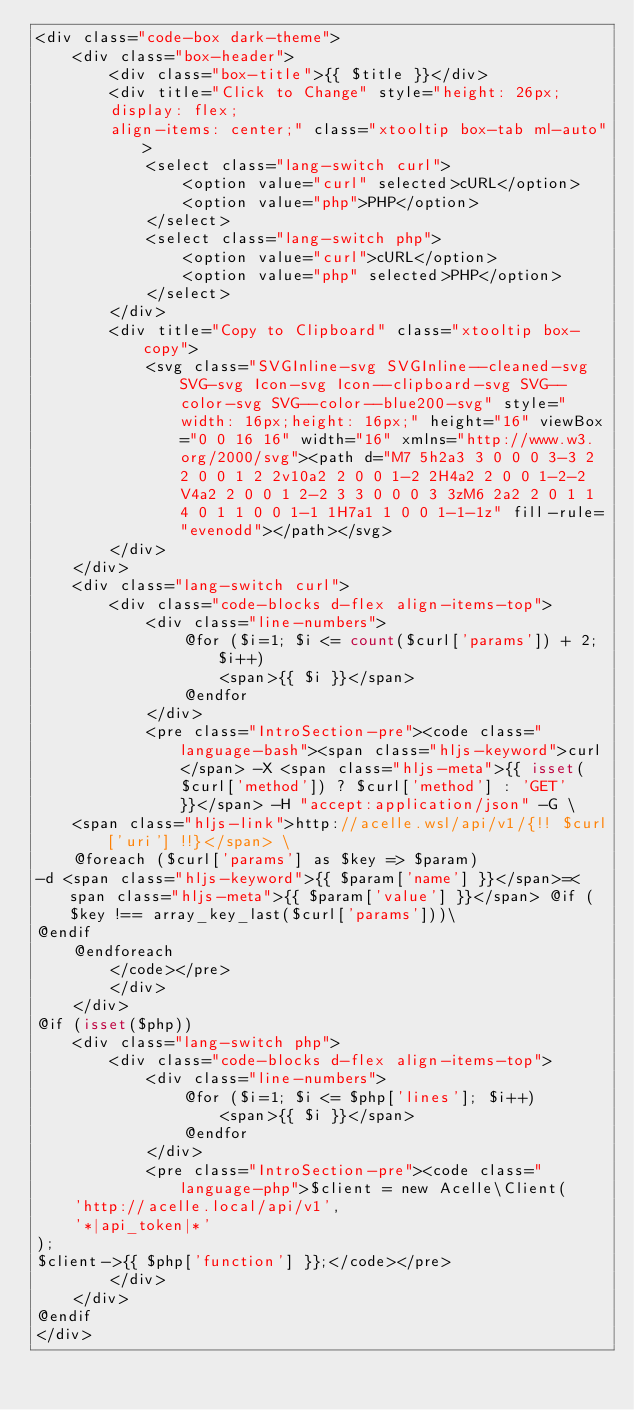Convert code to text. <code><loc_0><loc_0><loc_500><loc_500><_PHP_><div class="code-box dark-theme">
    <div class="box-header">
        <div class="box-title">{{ $title }}</div>
        <div title="Click to Change" style="height: 26px;
        display: flex;
        align-items: center;" class="xtooltip box-tab ml-auto">
            <select class="lang-switch curl">
                <option value="curl" selected>cURL</option>
                <option value="php">PHP</option>
            </select>
            <select class="lang-switch php">
                <option value="curl">cURL</option>
                <option value="php" selected>PHP</option>
            </select>
        </div>
        <div title="Copy to Clipboard" class="xtooltip box-copy">
            <svg class="SVGInline-svg SVGInline--cleaned-svg SVG-svg Icon-svg Icon--clipboard-svg SVG--color-svg SVG--color--blue200-svg" style="width: 16px;height: 16px;" height="16" viewBox="0 0 16 16" width="16" xmlns="http://www.w3.org/2000/svg"><path d="M7 5h2a3 3 0 0 0 3-3 2 2 0 0 1 2 2v10a2 2 0 0 1-2 2H4a2 2 0 0 1-2-2V4a2 2 0 0 1 2-2 3 3 0 0 0 3 3zM6 2a2 2 0 1 1 4 0 1 1 0 0 1-1 1H7a1 1 0 0 1-1-1z" fill-rule="evenodd"></path></svg>
        </div>
    </div>
    <div class="lang-switch curl">
        <div class="code-blocks d-flex align-items-top">
            <div class="line-numbers">
                @for ($i=1; $i <= count($curl['params']) + 2; $i++)
                    <span>{{ $i }}</span>
                @endfor
            </div>
            <pre class="IntroSection-pre"><code class="language-bash"><span class="hljs-keyword">curl</span> -X <span class="hljs-meta">{{ isset($curl['method']) ? $curl['method'] : 'GET' }}</span> -H "accept:application/json" -G \
    <span class="hljs-link">http://acelle.wsl/api/v1/{!! $curl['uri'] !!}</span> \
    @foreach ($curl['params'] as $key => $param)
-d <span class="hljs-keyword">{{ $param['name'] }}</span>=<span class="hljs-meta">{{ $param['value'] }}</span> @if ($key !== array_key_last($curl['params']))\
@endif
    @endforeach
        </code></pre>
        </div>
    </div>
@if (isset($php))
    <div class="lang-switch php">
        <div class="code-blocks d-flex align-items-top">
            <div class="line-numbers">
                @for ($i=1; $i <= $php['lines']; $i++)
                    <span>{{ $i }}</span>
                @endfor
            </div>
            <pre class="IntroSection-pre"><code class="language-php">$client = new Acelle\Client(
    'http://acelle.local/api/v1',
    '*|api_token|*'
);
$client->{{ $php['function'] }};</code></pre>
        </div>
    </div>
@endif
</div></code> 